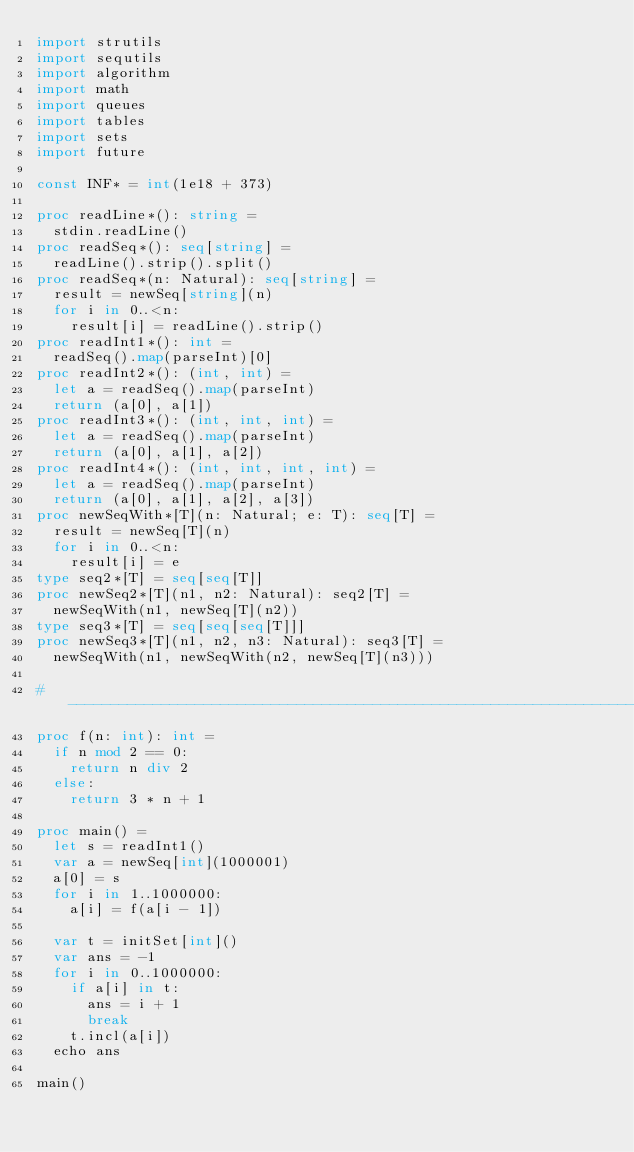Convert code to text. <code><loc_0><loc_0><loc_500><loc_500><_Nim_>import strutils
import sequtils
import algorithm
import math
import queues
import tables
import sets
import future

const INF* = int(1e18 + 373)

proc readLine*(): string =
  stdin.readLine()
proc readSeq*(): seq[string] =
  readLine().strip().split()
proc readSeq*(n: Natural): seq[string] =
  result = newSeq[string](n)
  for i in 0..<n:
    result[i] = readLine().strip()
proc readInt1*(): int =
  readSeq().map(parseInt)[0]
proc readInt2*(): (int, int) =
  let a = readSeq().map(parseInt)
  return (a[0], a[1])
proc readInt3*(): (int, int, int) =
  let a = readSeq().map(parseInt)
  return (a[0], a[1], a[2])
proc readInt4*(): (int, int, int, int) =
  let a = readSeq().map(parseInt)
  return (a[0], a[1], a[2], a[3])
proc newSeqWith*[T](n: Natural; e: T): seq[T] =
  result = newSeq[T](n)
  for i in 0..<n:
    result[i] = e
type seq2*[T] = seq[seq[T]]
proc newSeq2*[T](n1, n2: Natural): seq2[T] =
  newSeqWith(n1, newSeq[T](n2))
type seq3*[T] = seq[seq[seq[T]]]
proc newSeq3*[T](n1, n2, n3: Natural): seq3[T] =
  newSeqWith(n1, newSeqWith(n2, newSeq[T](n3)))

#------------------------------------------------------------------------------#
proc f(n: int): int =
  if n mod 2 == 0:
    return n div 2
  else:
    return 3 * n + 1

proc main() =
  let s = readInt1()
  var a = newSeq[int](1000001)
  a[0] = s
  for i in 1..1000000:
    a[i] = f(a[i - 1])

  var t = initSet[int]()
  var ans = -1
  for i in 0..1000000:
    if a[i] in t:
      ans = i + 1
      break
    t.incl(a[i])
  echo ans

main()

</code> 